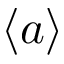Convert formula to latex. <formula><loc_0><loc_0><loc_500><loc_500>\langle a \rangle</formula> 